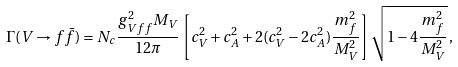Convert formula to latex. <formula><loc_0><loc_0><loc_500><loc_500>\Gamma ( V \rightarrow f \bar { f } ) = N _ { c } \frac { g _ { V f f } ^ { 2 } M _ { V } } { 1 2 \pi } \left [ c _ { V } ^ { 2 } + c _ { A } ^ { 2 } + 2 ( c _ { V } ^ { 2 } - 2 c _ { A } ^ { 2 } ) \frac { m _ { f } ^ { 2 } } { M _ { V } ^ { 2 } } \right ] \sqrt { 1 - 4 \frac { m _ { f } ^ { 2 } } { M _ { V } ^ { 2 } } } \, ,</formula> 